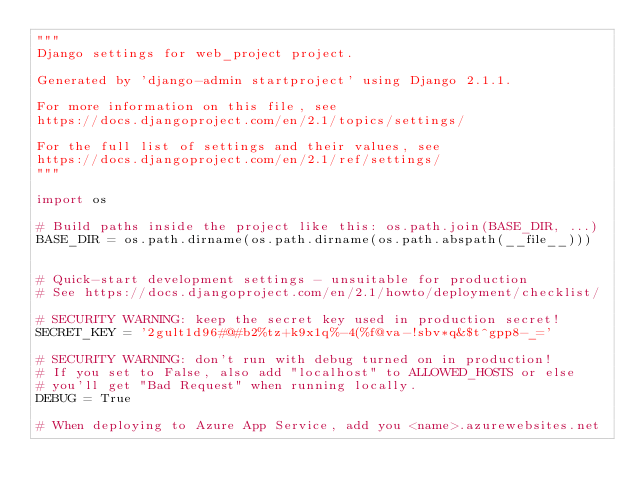Convert code to text. <code><loc_0><loc_0><loc_500><loc_500><_Python_>"""
Django settings for web_project project.

Generated by 'django-admin startproject' using Django 2.1.1.

For more information on this file, see
https://docs.djangoproject.com/en/2.1/topics/settings/

For the full list of settings and their values, see
https://docs.djangoproject.com/en/2.1/ref/settings/
"""

import os

# Build paths inside the project like this: os.path.join(BASE_DIR, ...)
BASE_DIR = os.path.dirname(os.path.dirname(os.path.abspath(__file__)))


# Quick-start development settings - unsuitable for production
# See https://docs.djangoproject.com/en/2.1/howto/deployment/checklist/

# SECURITY WARNING: keep the secret key used in production secret!
SECRET_KEY = '2gult1d96#@#b2%tz+k9x1q%-4(%f@va-!sbv*q&$t^gpp8-_='

# SECURITY WARNING: don't run with debug turned on in production!
# If you set to False, also add "localhost" to ALLOWED_HOSTS or else
# you'll get "Bad Request" when running locally.
DEBUG = True

# When deploying to Azure App Service, add you <name>.azurewebsites.net </code> 